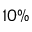Convert formula to latex. <formula><loc_0><loc_0><loc_500><loc_500>1 0 \%</formula> 